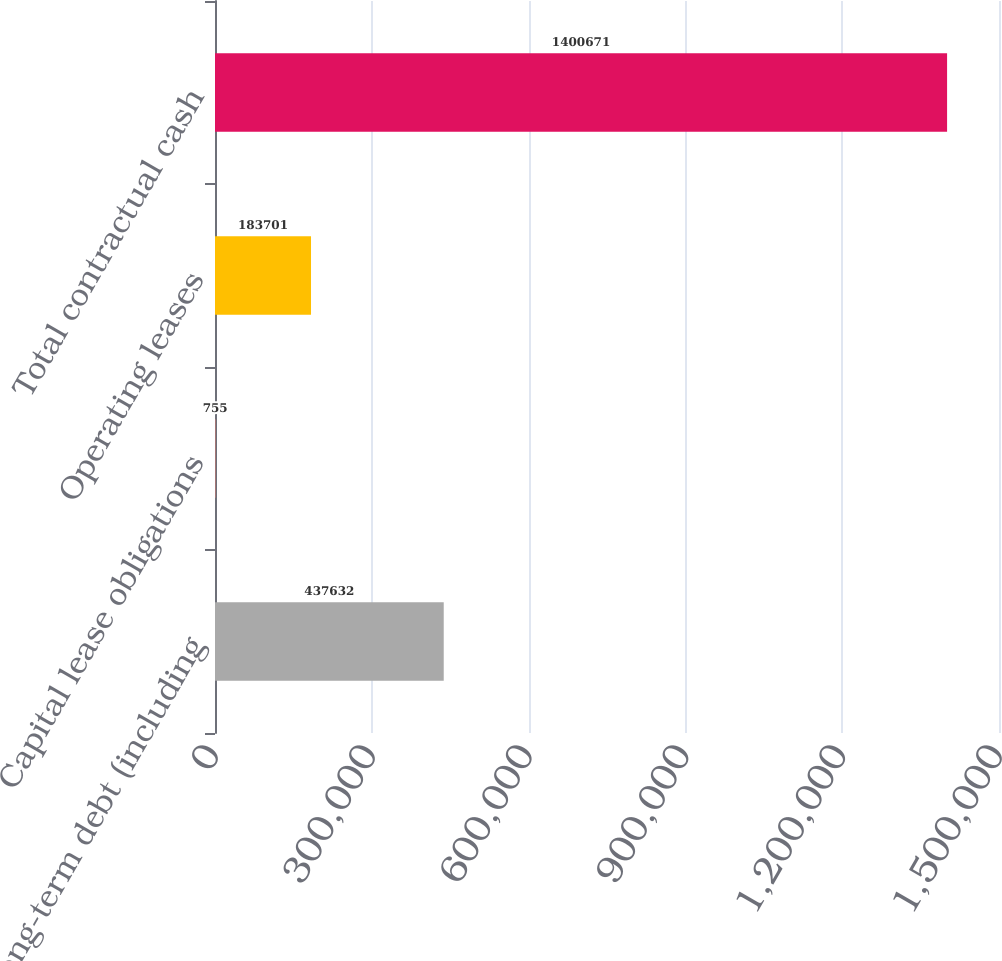<chart> <loc_0><loc_0><loc_500><loc_500><bar_chart><fcel>Long-term debt (including<fcel>Capital lease obligations<fcel>Operating leases<fcel>Total contractual cash<nl><fcel>437632<fcel>755<fcel>183701<fcel>1.40067e+06<nl></chart> 